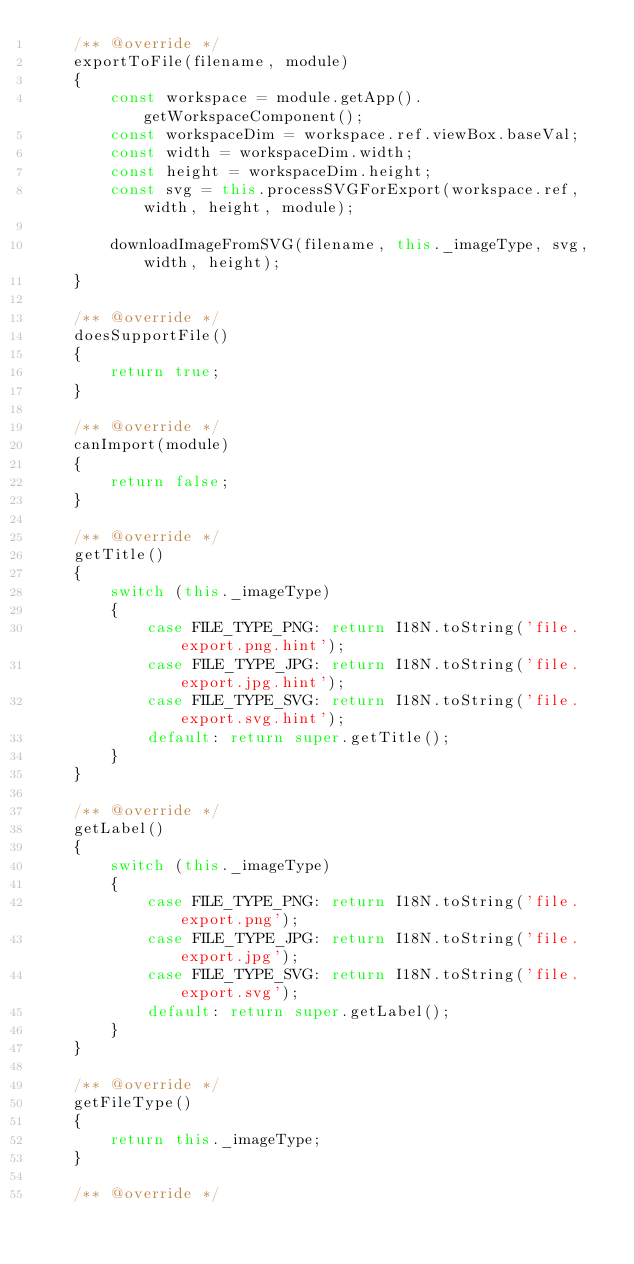<code> <loc_0><loc_0><loc_500><loc_500><_JavaScript_>    /** @override */
    exportToFile(filename, module)
    {
        const workspace = module.getApp().getWorkspaceComponent();
        const workspaceDim = workspace.ref.viewBox.baseVal;
        const width = workspaceDim.width;
        const height = workspaceDim.height;
        const svg = this.processSVGForExport(workspace.ref, width, height, module);

        downloadImageFromSVG(filename, this._imageType, svg, width, height);
    }

    /** @override */
    doesSupportFile()
    {
        return true;
    }

    /** @override */
    canImport(module)
    {
        return false;
    }

    /** @override */
    getTitle()
    {
        switch (this._imageType)
        {
            case FILE_TYPE_PNG: return I18N.toString('file.export.png.hint');
            case FILE_TYPE_JPG: return I18N.toString('file.export.jpg.hint');
            case FILE_TYPE_SVG: return I18N.toString('file.export.svg.hint');
            default: return super.getTitle();
        }
    }

    /** @override */
    getLabel()
    {
        switch (this._imageType)
        {
            case FILE_TYPE_PNG: return I18N.toString('file.export.png');
            case FILE_TYPE_JPG: return I18N.toString('file.export.jpg');
            case FILE_TYPE_SVG: return I18N.toString('file.export.svg');
            default: return super.getLabel();
        }
    }

    /** @override */
    getFileType()
    {
        return this._imageType;
    }

    /** @override */</code> 